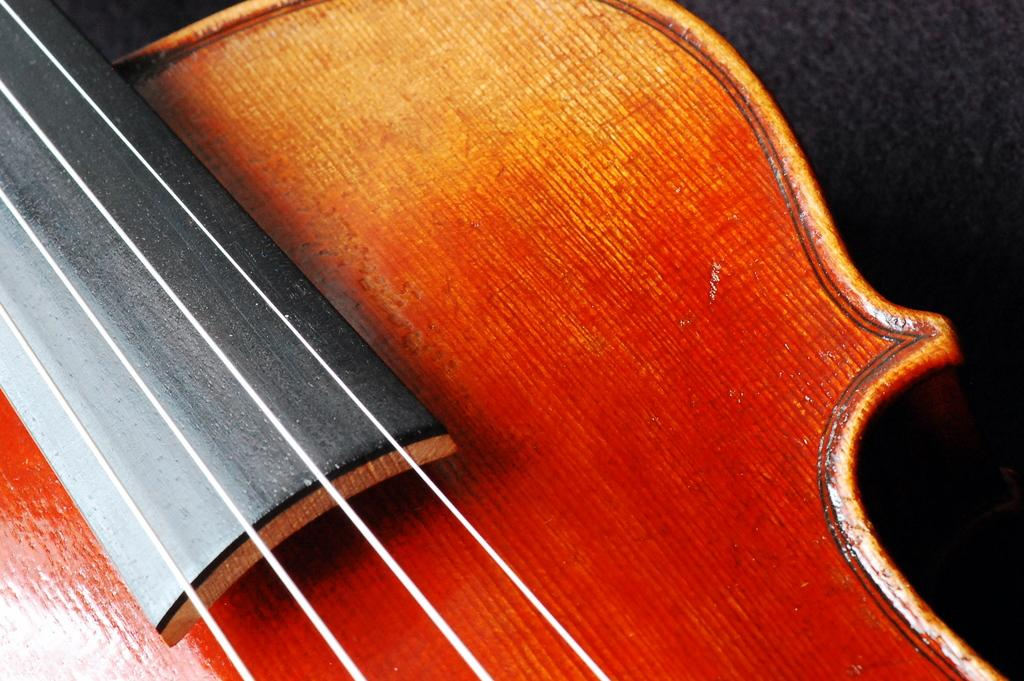What is the main subject of the image? The main subject of the image is guitar strings. Can you describe the guitar strings in more detail? Unfortunately, the facts provided do not give any additional details about the guitar strings. What type of cable is being used to hold the guitar strings in place? There is no cable present in the image; it only features guitar strings. 